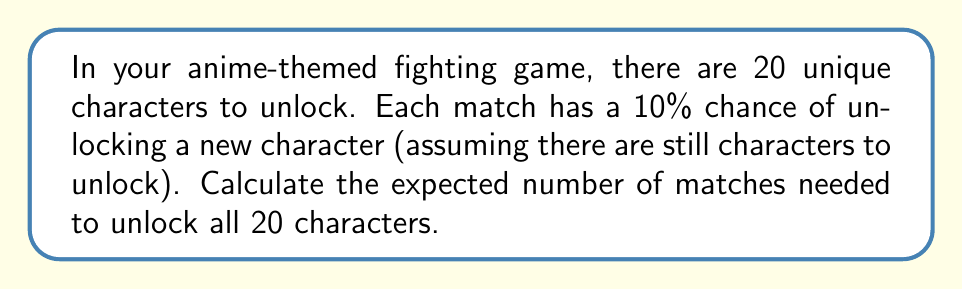Provide a solution to this math problem. Let's approach this step-by-step using the concept of the Coupon Collector's Problem:

1) First, we need to calculate the expected number of matches to unlock each character:

   For the 1st character: $E_1 = \frac{1}{0.1} = 10$ matches
   For the 2nd character: $E_2 = \frac{1}{0.1} \cdot \frac{20}{19} = 10.53$ matches
   For the 3rd character: $E_3 = \frac{1}{0.1} \cdot \frac{20}{18} = 11.11$ matches
   ...
   For the 20th character: $E_{20} = \frac{1}{0.1} \cdot \frac{20}{1} = 200$ matches

2) The general formula for the expected number of matches to unlock the $k$-th character is:

   $$E_k = \frac{1}{0.1} \cdot \frac{20}{21-k}$$

3) The total expected number of matches is the sum of all these expectations:

   $$E_{total} = \sum_{k=1}^{20} E_k = \frac{10}{20} \sum_{k=1}^{20} \frac{20}{21-k}$$

4) This sum can be simplified to:

   $$E_{total} = 10 \cdot 20 \cdot (H_{20})$$

   Where $H_{20}$ is the 20th Harmonic number.

5) The 20th Harmonic number is approximately 3.597739657.

6) Therefore, the expected number of matches is:

   $$E_{total} = 10 \cdot 20 \cdot 3.597739657 = 719.5479314$$

7) Rounding to the nearest whole number (as we can't have a fractional match), we get 720 matches.
Answer: 720 matches 